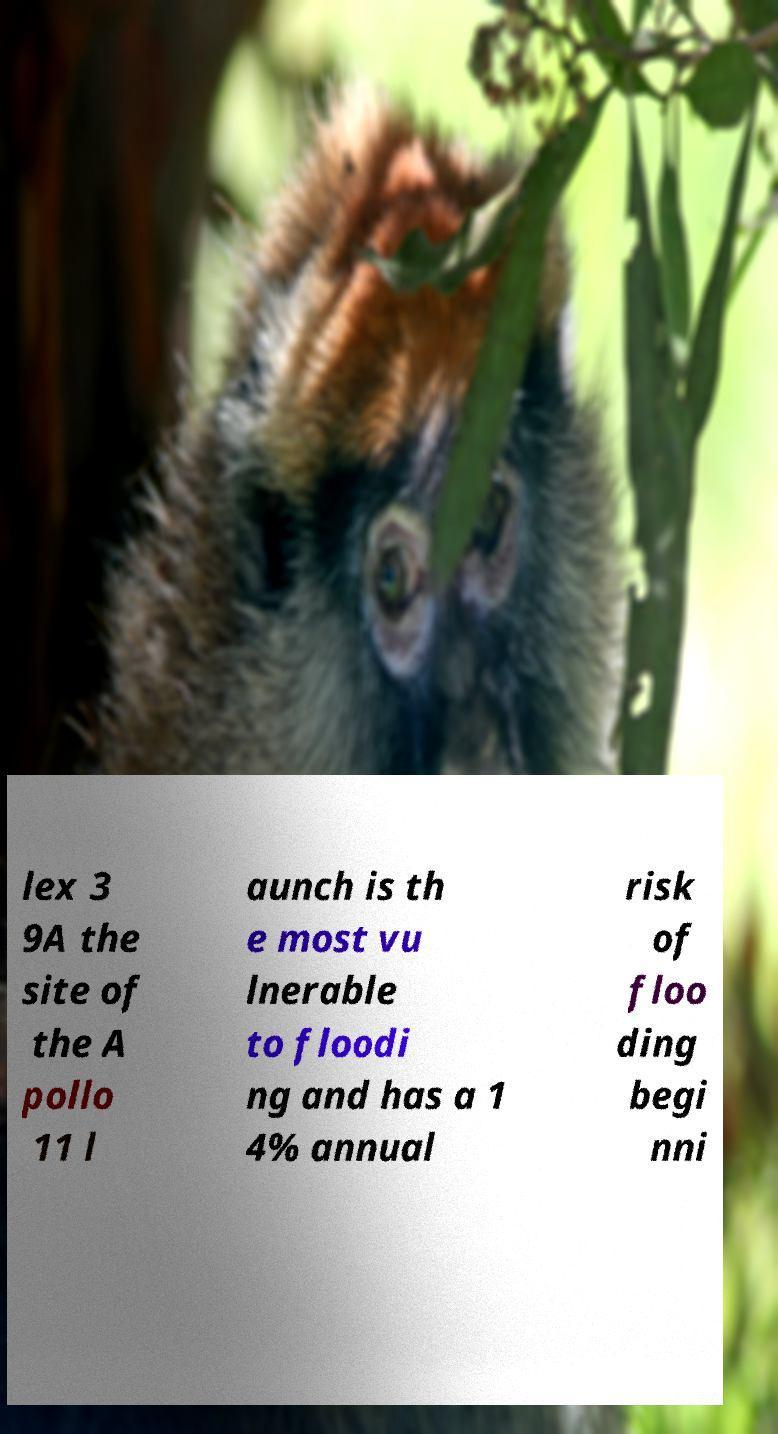There's text embedded in this image that I need extracted. Can you transcribe it verbatim? lex 3 9A the site of the A pollo 11 l aunch is th e most vu lnerable to floodi ng and has a 1 4% annual risk of floo ding begi nni 